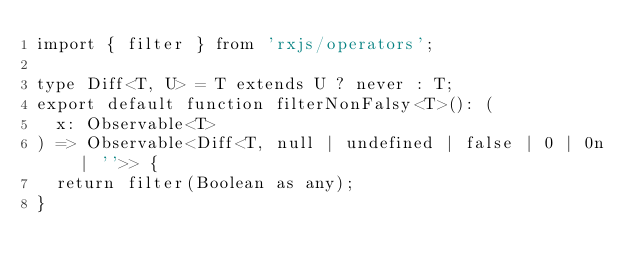<code> <loc_0><loc_0><loc_500><loc_500><_TypeScript_>import { filter } from 'rxjs/operators';

type Diff<T, U> = T extends U ? never : T;
export default function filterNonFalsy<T>(): (
  x: Observable<T>
) => Observable<Diff<T, null | undefined | false | 0 | 0n | ''>> {
  return filter(Boolean as any);
}
</code> 